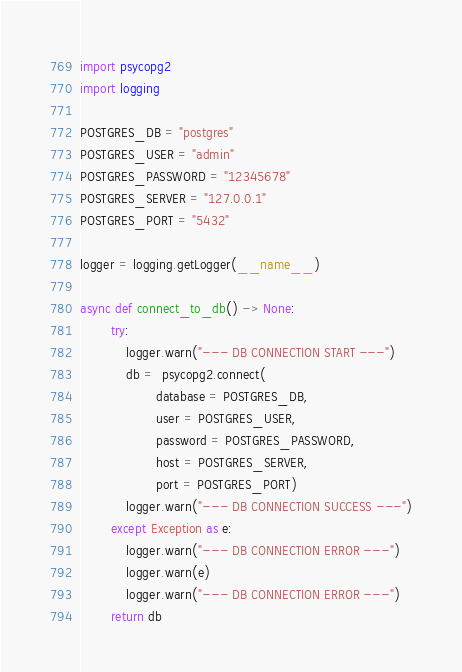<code> <loc_0><loc_0><loc_500><loc_500><_Python_>import psycopg2
import logging

POSTGRES_DB = "postgres"
POSTGRES_USER = "admin"
POSTGRES_PASSWORD = "12345678"
POSTGRES_SERVER = "127.0.0.1"
POSTGRES_PORT = "5432"

logger = logging.getLogger(__name__)

async def connect_to_db() -> None:
        try:
            logger.warn("--- DB CONNECTION START ---")
            db =  psycopg2.connect(
                    database = POSTGRES_DB,
                    user = POSTGRES_USER,
                    password = POSTGRES_PASSWORD,
                    host = POSTGRES_SERVER,
                    port = POSTGRES_PORT)
            logger.warn("--- DB CONNECTION SUCCESS ---")
        except Exception as e:
            logger.warn("--- DB CONNECTION ERROR ---")
            logger.warn(e)
            logger.warn("--- DB CONNECTION ERROR ---")
        return db
</code> 